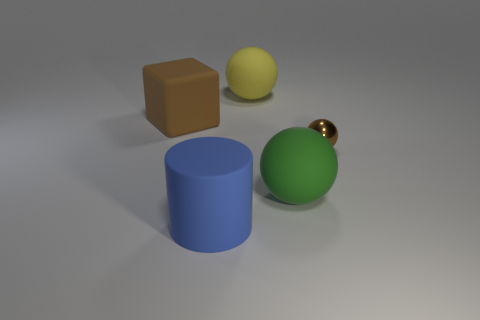Add 5 blue rubber things. How many objects exist? 10 Subtract all spheres. How many objects are left? 2 Add 1 big green matte objects. How many big green matte objects are left? 2 Add 2 large purple cylinders. How many large purple cylinders exist? 2 Subtract 0 cyan cylinders. How many objects are left? 5 Subtract all small blue shiny blocks. Subtract all big brown rubber objects. How many objects are left? 4 